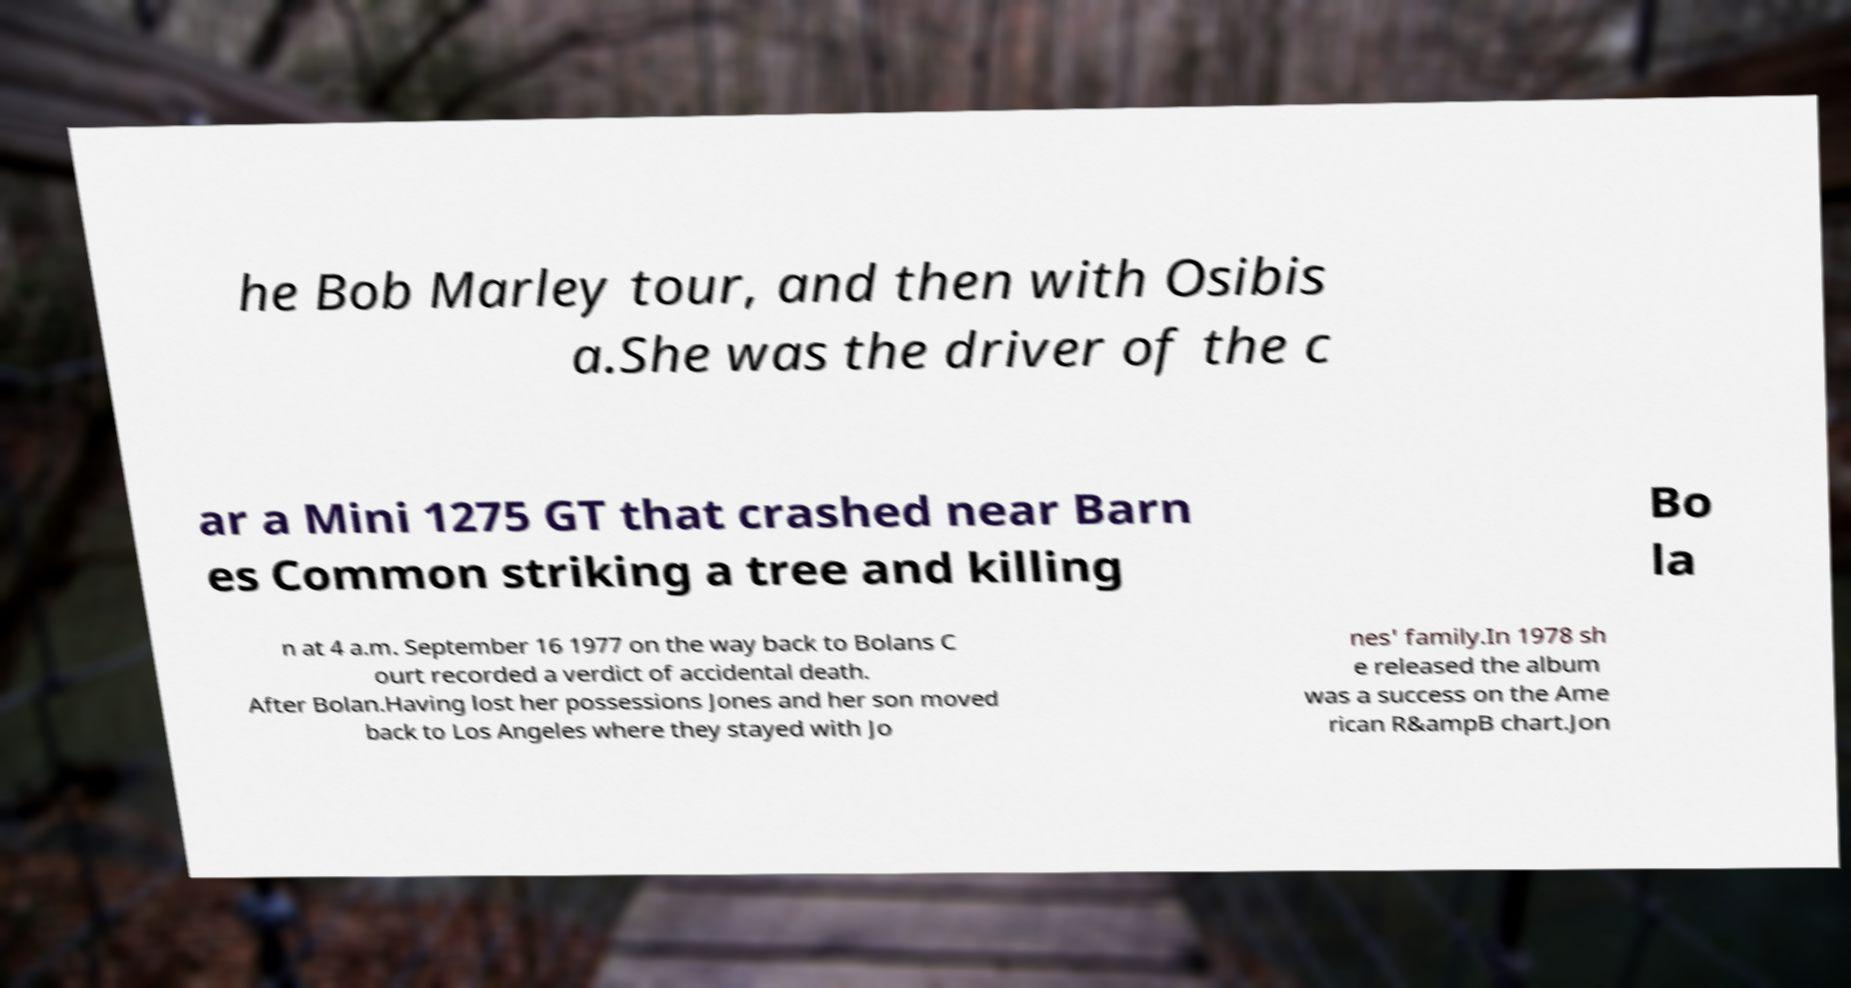What messages or text are displayed in this image? I need them in a readable, typed format. he Bob Marley tour, and then with Osibis a.She was the driver of the c ar a Mini 1275 GT that crashed near Barn es Common striking a tree and killing Bo la n at 4 a.m. September 16 1977 on the way back to Bolans C ourt recorded a verdict of accidental death. After Bolan.Having lost her possessions Jones and her son moved back to Los Angeles where they stayed with Jo nes' family.In 1978 sh e released the album was a success on the Ame rican R&ampB chart.Jon 